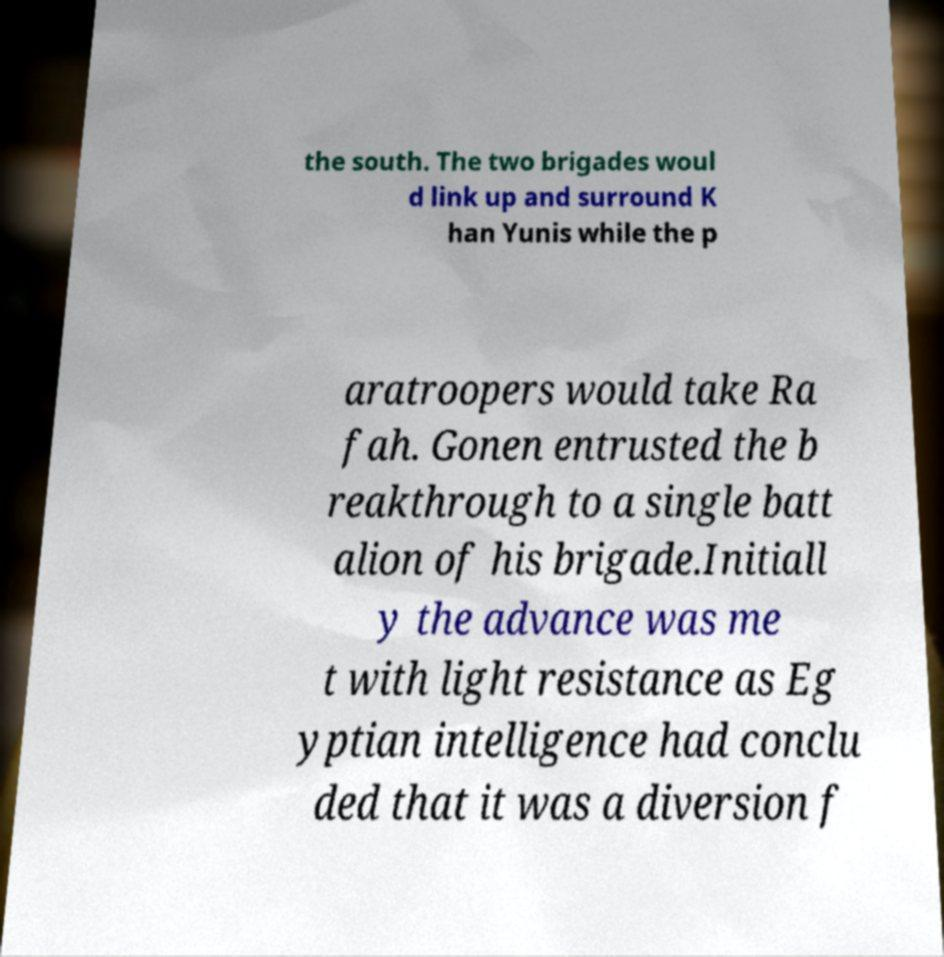Could you assist in decoding the text presented in this image and type it out clearly? the south. The two brigades woul d link up and surround K han Yunis while the p aratroopers would take Ra fah. Gonen entrusted the b reakthrough to a single batt alion of his brigade.Initiall y the advance was me t with light resistance as Eg yptian intelligence had conclu ded that it was a diversion f 